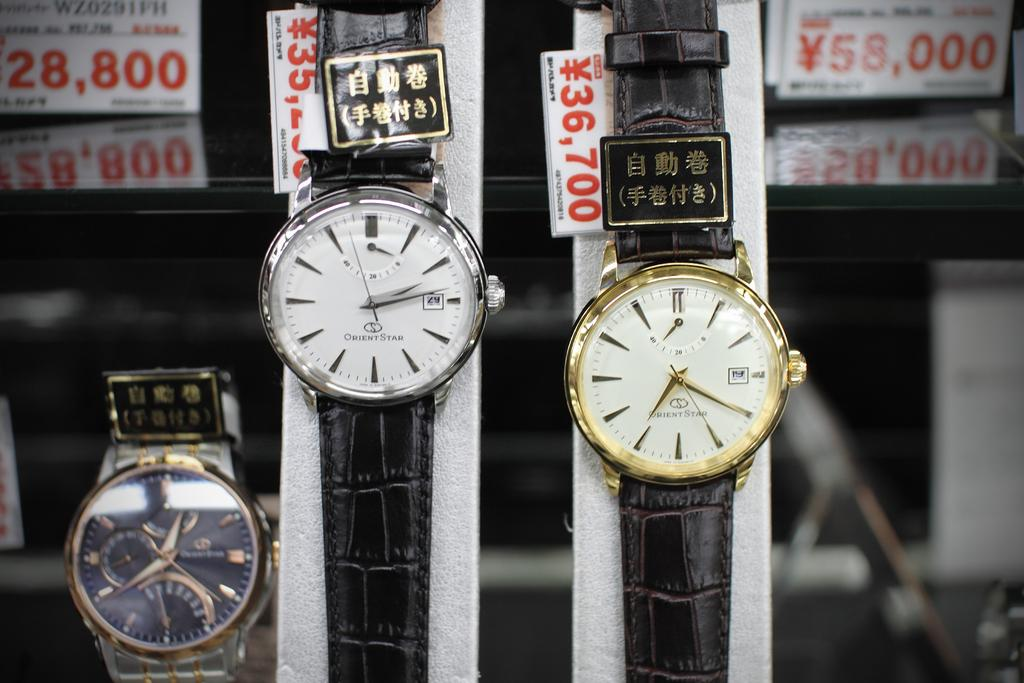Provide a one-sentence caption for the provided image. One of the watches in this store display sells for 36,700 yen. 